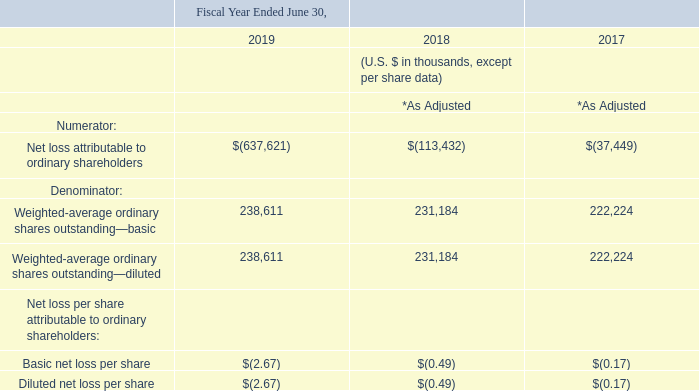17. Earnings Per Share
Basic earnings per share is computed by dividing the net income attributable to ordinary shareholders by the weighted-average number of ordinary shares outstanding during the period. Diluted earnings per share is computed by giving effect to all potential weighted-average dilutive shares. The dilutive effect of outstanding awards is reflected in diluted earnings per share by application of the treasury stock method.
A reconciliation of the calculation of basic and diluted loss per share is as follows:
* As adjusted to reflect the impact of the full retrospective adoption of IFRS 15. See Note 2 for further details.
For fiscal years ended June 30, 2019, 2018 and 2017 , 9.6 million, 12.8 million and 13.8 million, respectively of potentially anti-dilutive shares were excluded from the computation of net loss per share.
What is the number of potentially anti-dilutive shares that were excluded for fiscal years ended June 30, 2017, 2018 and 2019 respectively?  13.8 million, 12.8 million, 9.6 million. How is basic earnings per share computed? Dividing the net income attributable to ordinary shareholders by the weighted-average number of ordinary shares outstanding during the period. What is the  Net loss attributable to ordinary shareholders for fiscal year 2019?
Answer scale should be: thousand. $(637,621). In fiscal year ended June 30, 2019, what is the difference in the weighted-average ordinary shares outstanding between the basic and the diluted? 238,611-238,611
Answer: 0. What is the average basic net loss per share for fiscal years ended June 30, 2017, 2018 and 2019? -(2.67+0.49+0.17)/3
Answer: -1.11. What is the percentage change for the weighted-average ordinary basic shares outstanding between fiscal years ended June 30, 2018 and 2019?
Answer scale should be: percent. (238,611-231,184)/231,184
Answer: 3.21. 